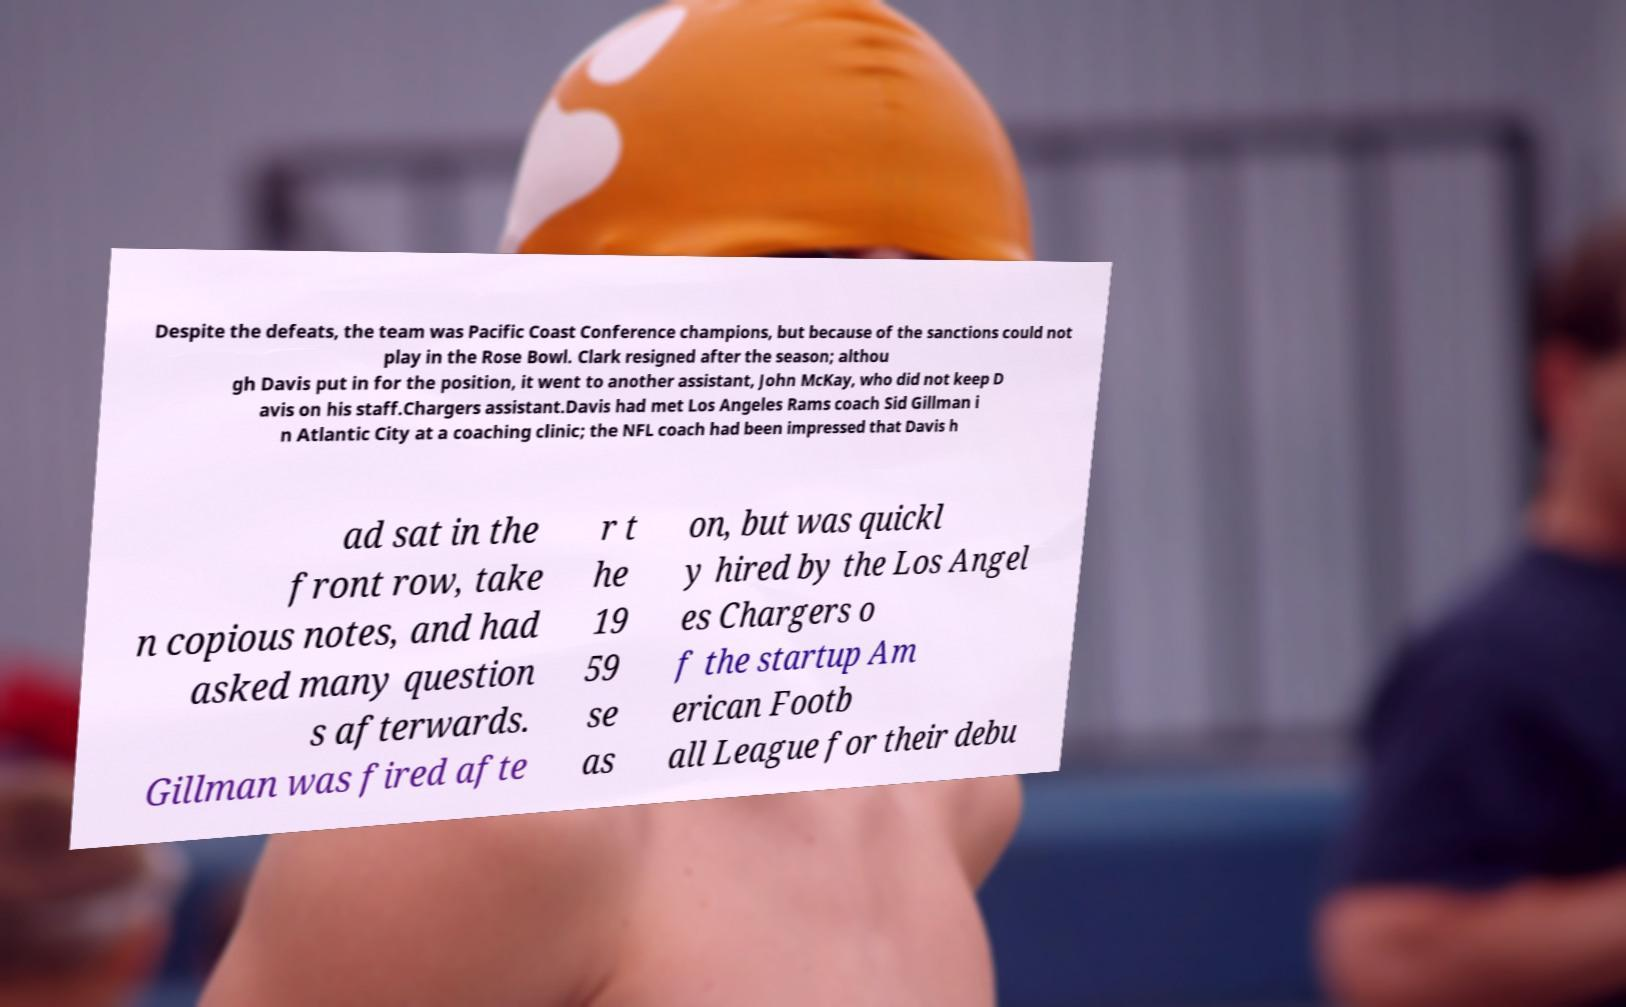Can you read and provide the text displayed in the image?This photo seems to have some interesting text. Can you extract and type it out for me? Despite the defeats, the team was Pacific Coast Conference champions, but because of the sanctions could not play in the Rose Bowl. Clark resigned after the season; althou gh Davis put in for the position, it went to another assistant, John McKay, who did not keep D avis on his staff.Chargers assistant.Davis had met Los Angeles Rams coach Sid Gillman i n Atlantic City at a coaching clinic; the NFL coach had been impressed that Davis h ad sat in the front row, take n copious notes, and had asked many question s afterwards. Gillman was fired afte r t he 19 59 se as on, but was quickl y hired by the Los Angel es Chargers o f the startup Am erican Footb all League for their debu 